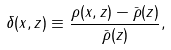<formula> <loc_0><loc_0><loc_500><loc_500>\delta ( { x } , z ) \equiv \frac { \rho ( { x } , z ) - \bar { \rho } ( z ) } { \bar { \rho } ( z ) } ,</formula> 